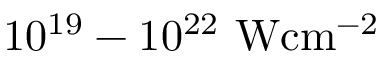<formula> <loc_0><loc_0><loc_500><loc_500>1 0 ^ { 1 9 } - 1 0 ^ { 2 2 } W c m ^ { - 2 }</formula> 